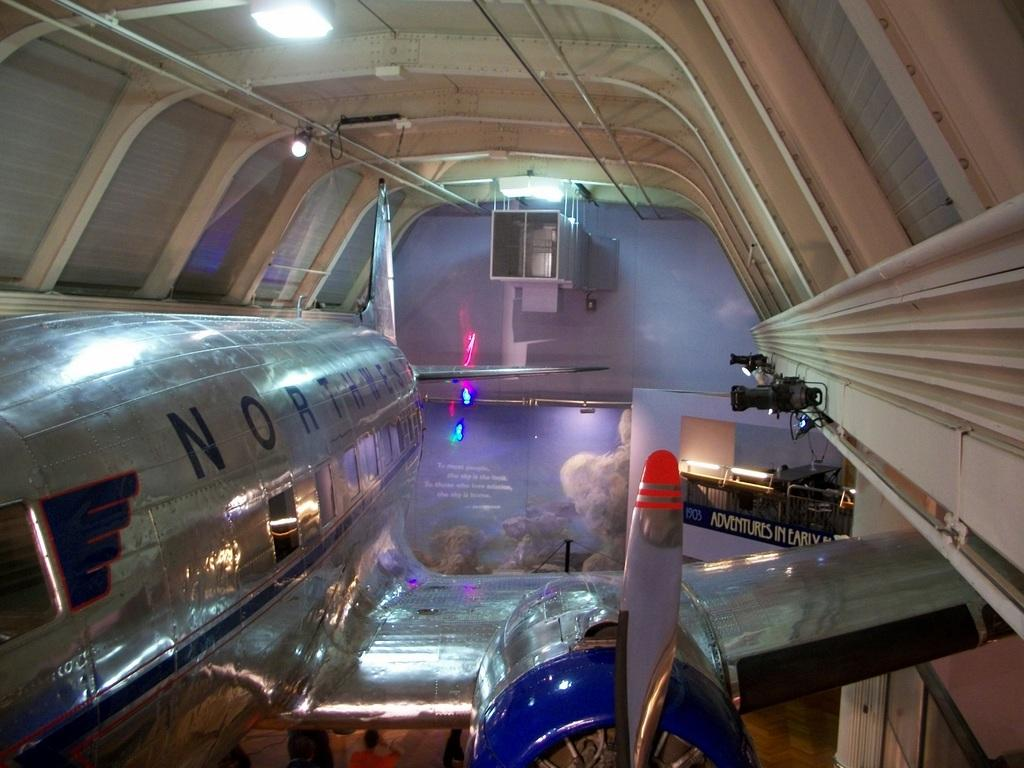What is the main subject of the picture? The main subject of the picture is a plane. Are there any other objects in the picture besides the plane? Yes, there are other objects above the plane. What type of hammer is being used by the person in the image? There is no person or hammer present in the image; it only features a plane and other objects above it. 